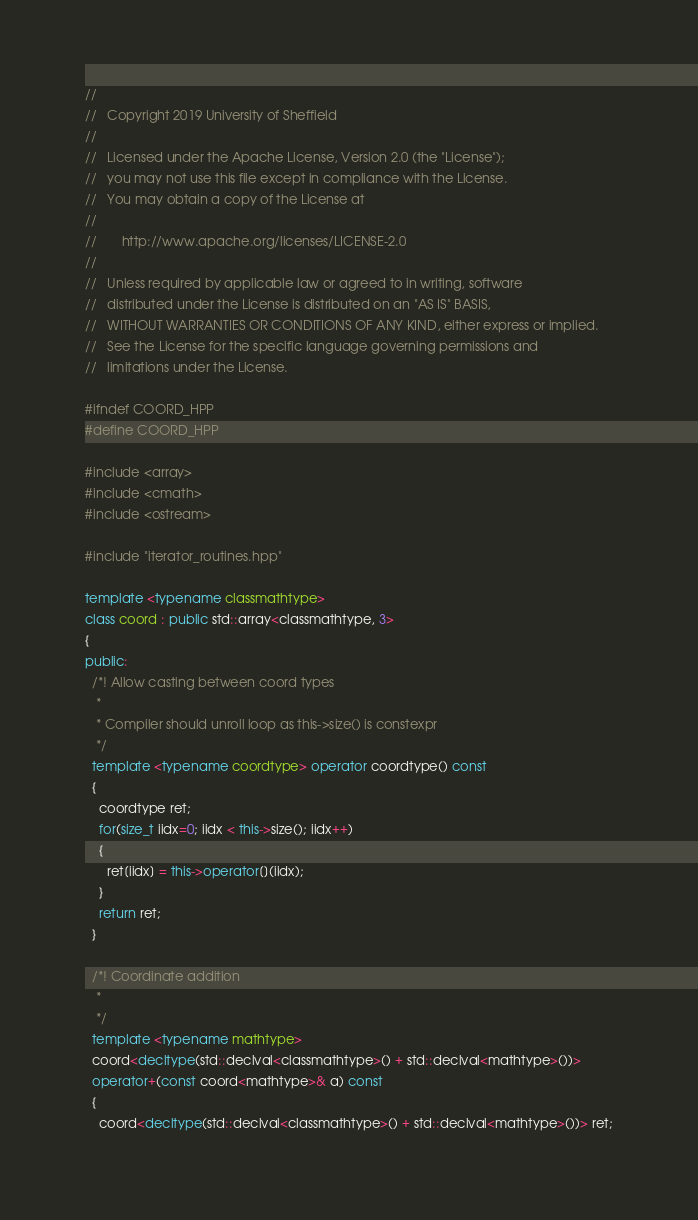<code> <loc_0><loc_0><loc_500><loc_500><_C++_>//
//   Copyright 2019 University of Sheffield
//
//   Licensed under the Apache License, Version 2.0 (the "License");
//   you may not use this file except in compliance with the License.
//   You may obtain a copy of the License at
//
//       http://www.apache.org/licenses/LICENSE-2.0
//
//   Unless required by applicable law or agreed to in writing, software
//   distributed under the License is distributed on an "AS IS" BASIS,
//   WITHOUT WARRANTIES OR CONDITIONS OF ANY KIND, either express or implied.
//   See the License for the specific language governing permissions and
//   limitations under the License.

#ifndef COORD_HPP
#define COORD_HPP

#include <array>
#include <cmath>
#include <ostream>

#include "iterator_routines.hpp"

template <typename classmathtype> 
class coord : public std::array<classmathtype, 3>
{
public: 
  /*! Allow casting between coord types
   *
   * Compiler should unroll loop as this->size() is constexpr
   */
  template <typename coordtype> operator coordtype() const
  {
    coordtype ret;
    for(size_t iidx=0; iidx < this->size(); iidx++)
    {
      ret[iidx] = this->operator[](iidx);
    }
    return ret;
  }

  /*! Coordinate addition
   *
   */
  template <typename mathtype>
  coord<decltype(std::declval<classmathtype>() + std::declval<mathtype>())>
  operator+(const coord<mathtype>& a) const
  {
    coord<decltype(std::declval<classmathtype>() + std::declval<mathtype>())> ret;</code> 